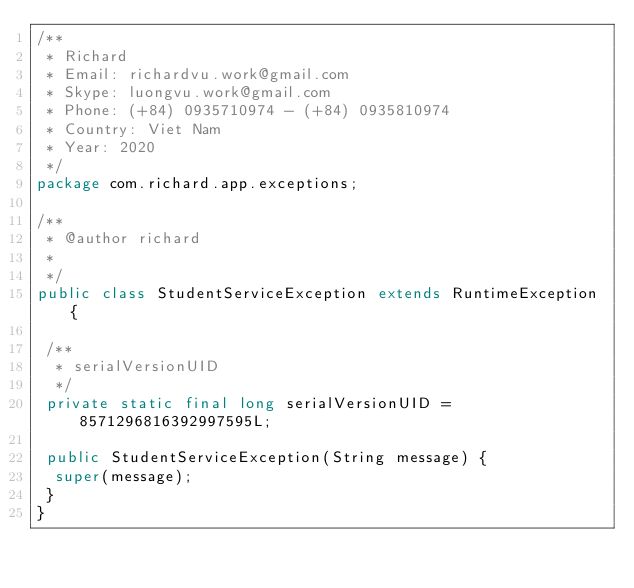<code> <loc_0><loc_0><loc_500><loc_500><_Java_>/**
 * Richard
 * Email: richardvu.work@gmail.com
 * Skype: luongvu.work@gmail.com
 * Phone: (+84) 0935710974 - (+84) 0935810974
 * Country: Viet Nam
 * Year: 2020
 */
package com.richard.app.exceptions;

/**
 * @author richard
 *
 */
public class StudentServiceException extends RuntimeException {

 /**
  * serialVersionUID
  */
 private static final long serialVersionUID = 8571296816392997595L;

 public StudentServiceException(String message) {
  super(message);
 }
}
</code> 